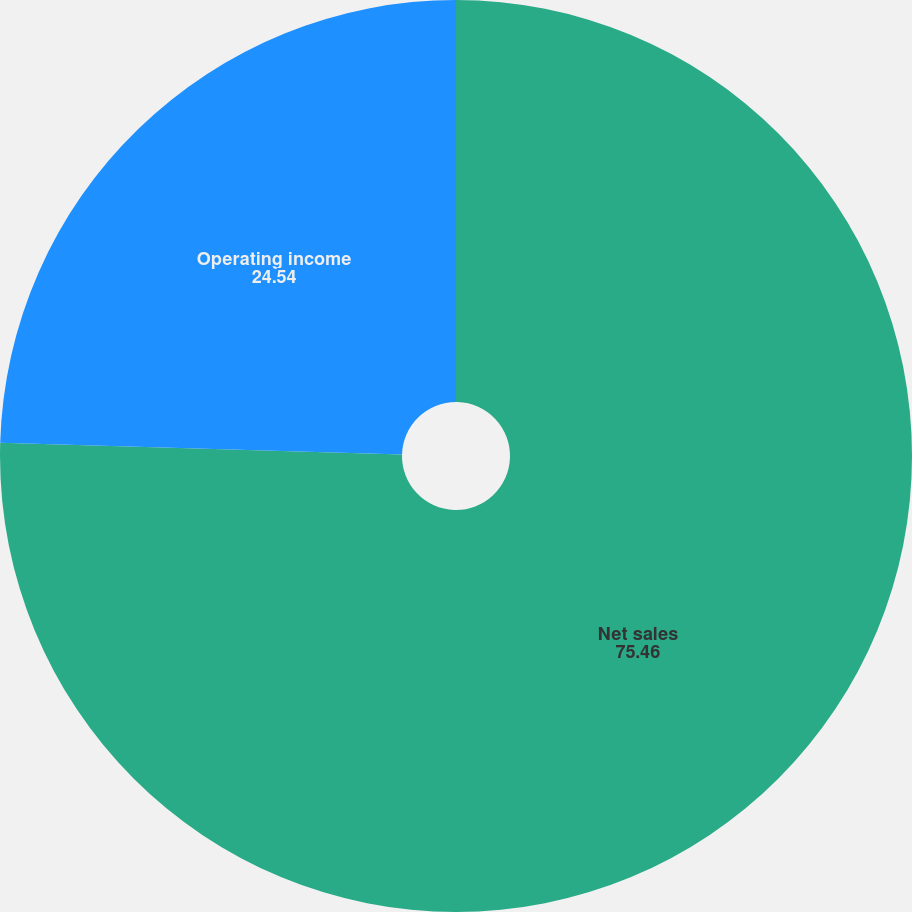Convert chart to OTSL. <chart><loc_0><loc_0><loc_500><loc_500><pie_chart><fcel>Net sales<fcel>Operating income<nl><fcel>75.46%<fcel>24.54%<nl></chart> 